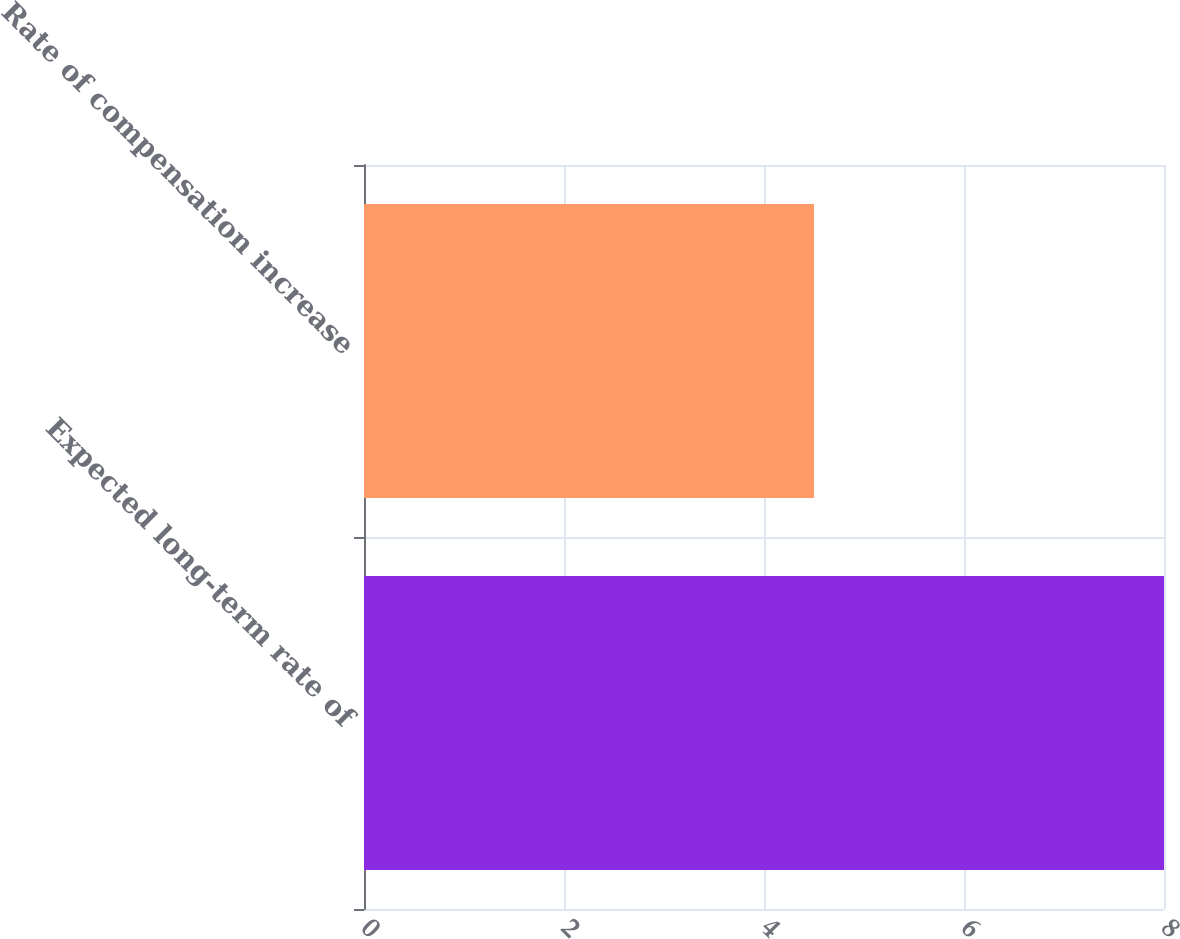Convert chart. <chart><loc_0><loc_0><loc_500><loc_500><bar_chart><fcel>Expected long-term rate of<fcel>Rate of compensation increase<nl><fcel>8<fcel>4.5<nl></chart> 